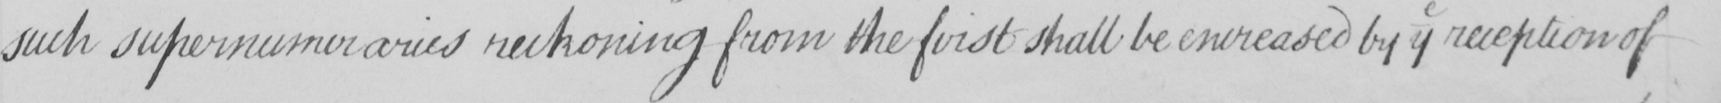What text is written in this handwritten line? such supernumeraries reckoning from the first shall be encreased by y reception of 